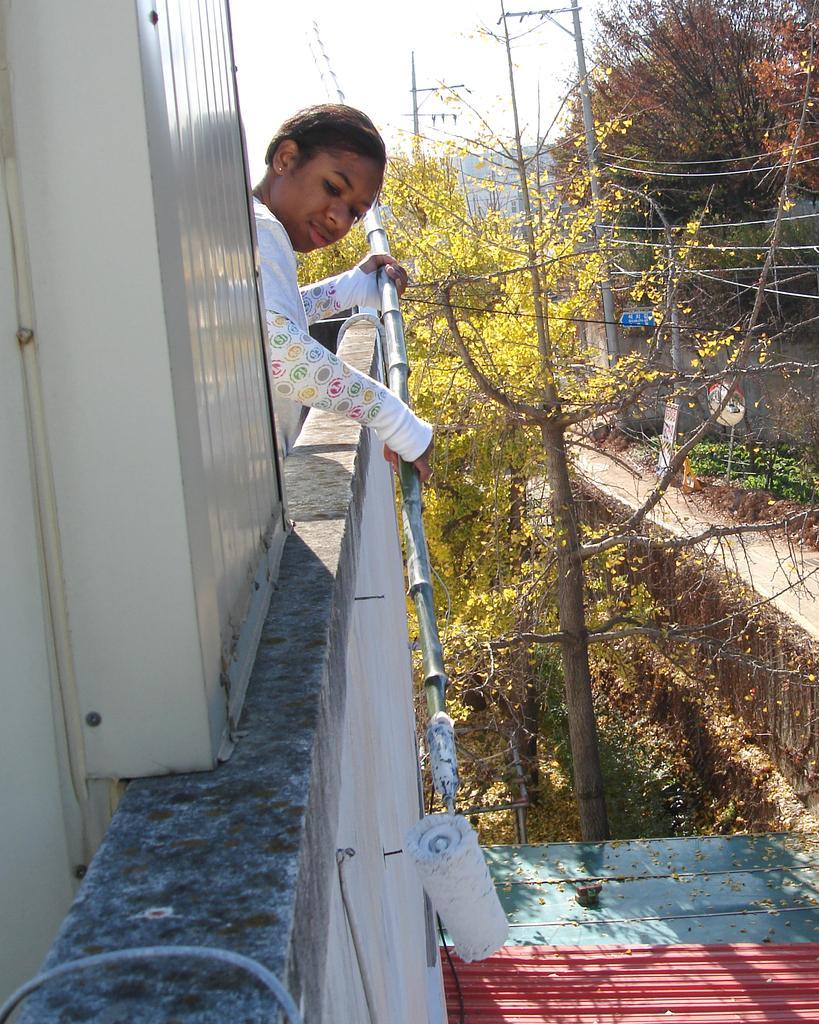Describe this image in one or two sentences. This image consists of a woman painting a wall. On the left, we can see a building. At the bottom, there is a shed. In the background, there are many trees and poles. At the top, there is sky. On the right, it looks like a road. 